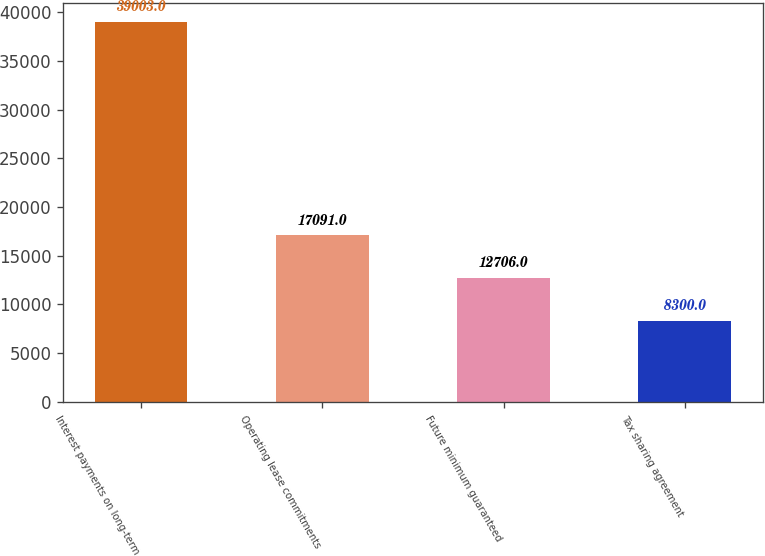Convert chart to OTSL. <chart><loc_0><loc_0><loc_500><loc_500><bar_chart><fcel>Interest payments on long-term<fcel>Operating lease commitments<fcel>Future minimum guaranteed<fcel>Tax sharing agreement<nl><fcel>39003<fcel>17091<fcel>12706<fcel>8300<nl></chart> 